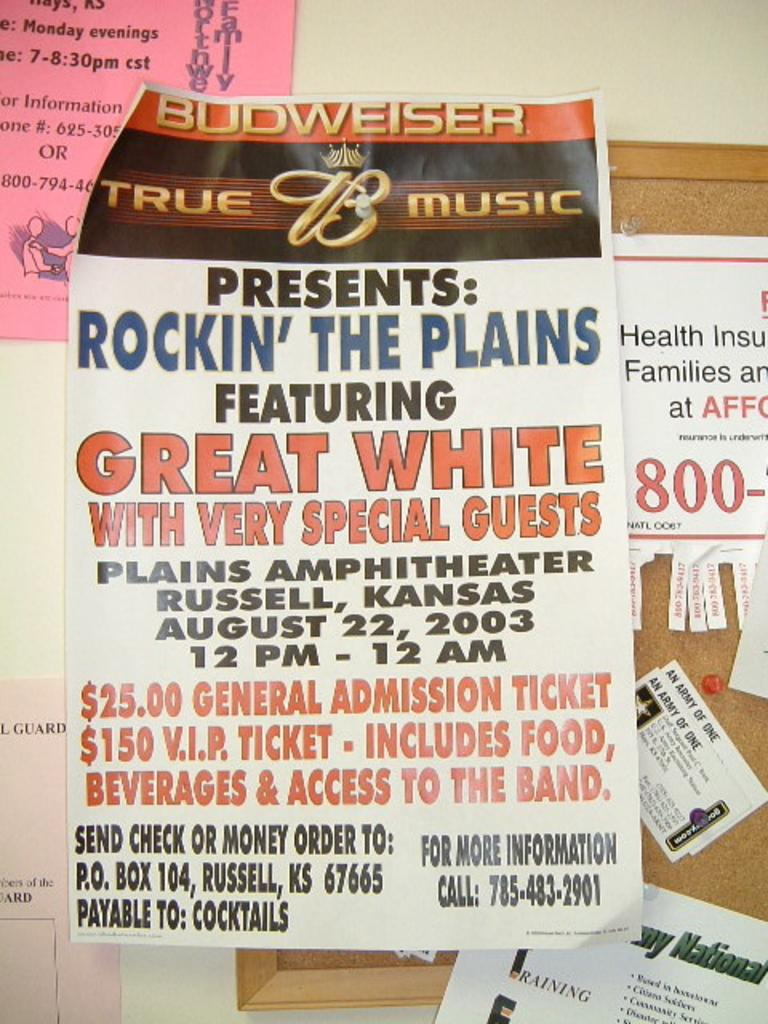<image>
Share a concise interpretation of the image provided. An advertisemnt that presents Great White with special guests at the Rockin' the Plains concert. 